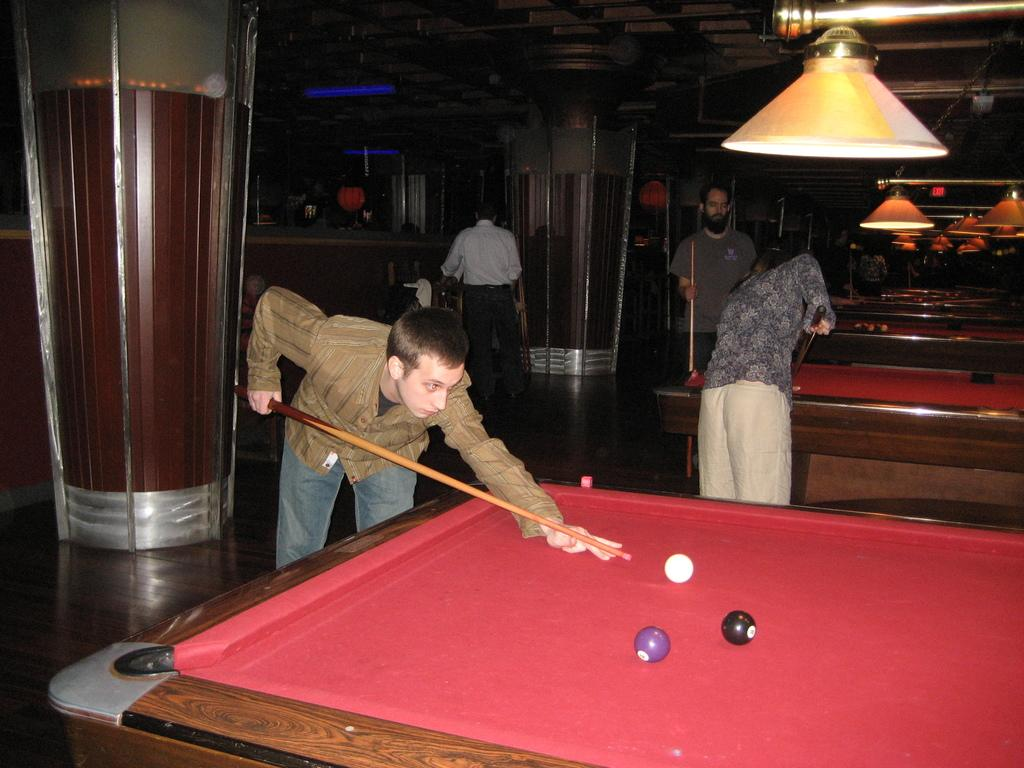What are the three persons in the image doing? The three persons in the image are playing snooker. Can you describe the person standing in the top center of the image? There is a person standing on the top center of the image. What type of instrument is the person on the top center of the image playing? There is no instrument present in the image; the person is simply standing. 